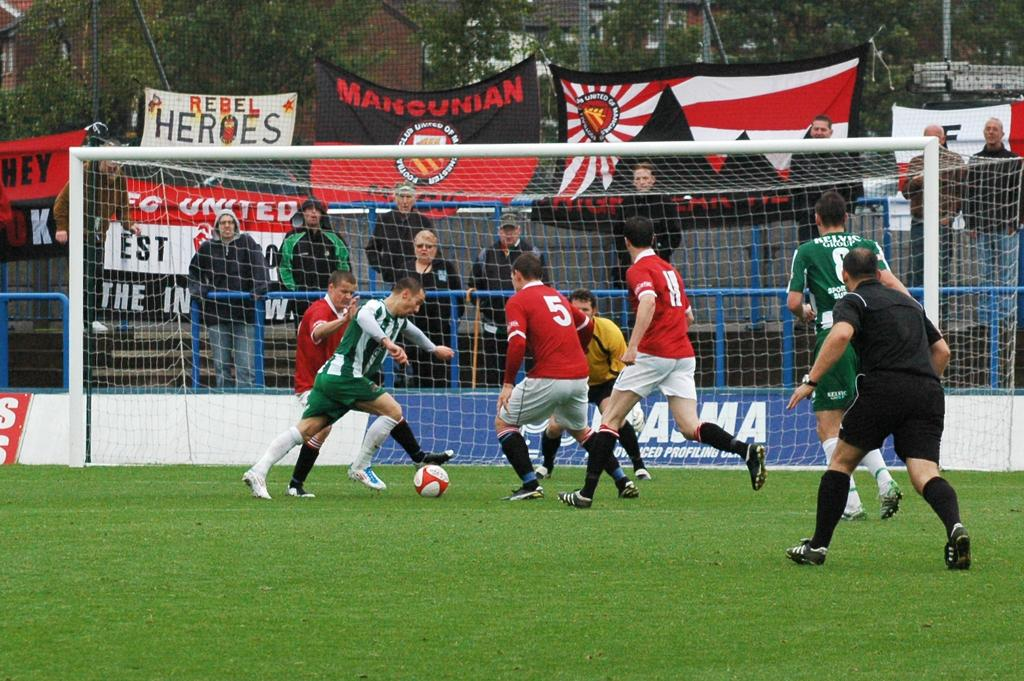What type of barrier can be seen in the image? There is a fence in the image. What is attached to the fence in the image? There is a flag in the image. What activity are the people engaged in? The people are playing with a football in the image. How many bikes are visible in the image? There are no bikes present in the image. What is the limit of the football field in the image? The image does not provide information about the size or limit of the football field. 